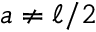Convert formula to latex. <formula><loc_0><loc_0><loc_500><loc_500>a \neq \ell / 2</formula> 